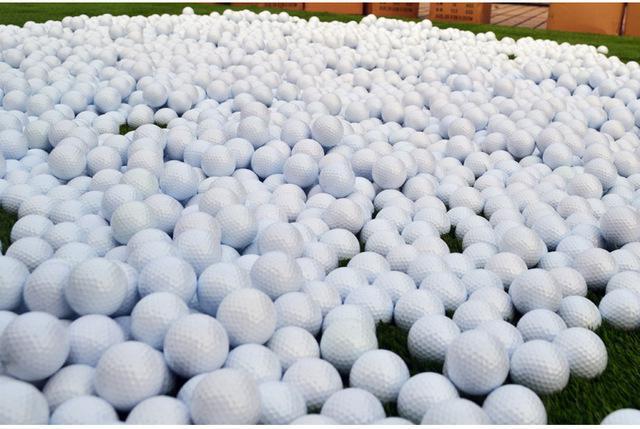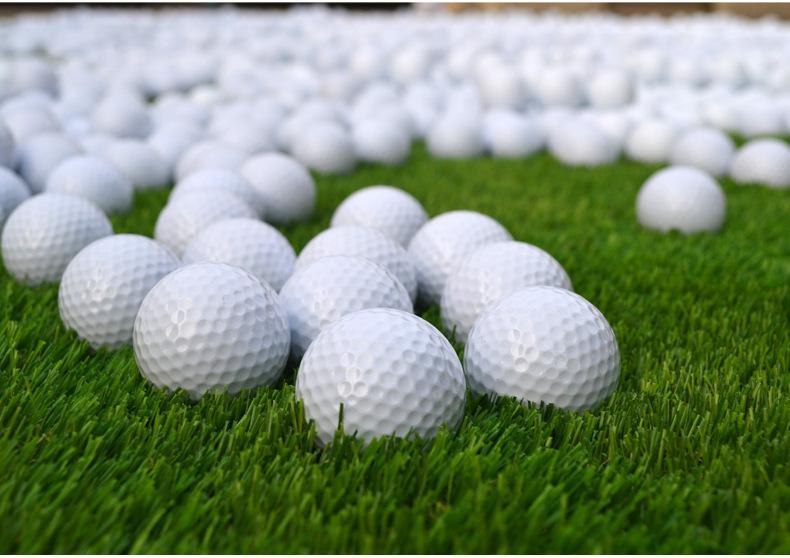The first image is the image on the left, the second image is the image on the right. Analyze the images presented: Is the assertion "All golf balls shown are plain and unmarked." valid? Answer yes or no. Yes. 